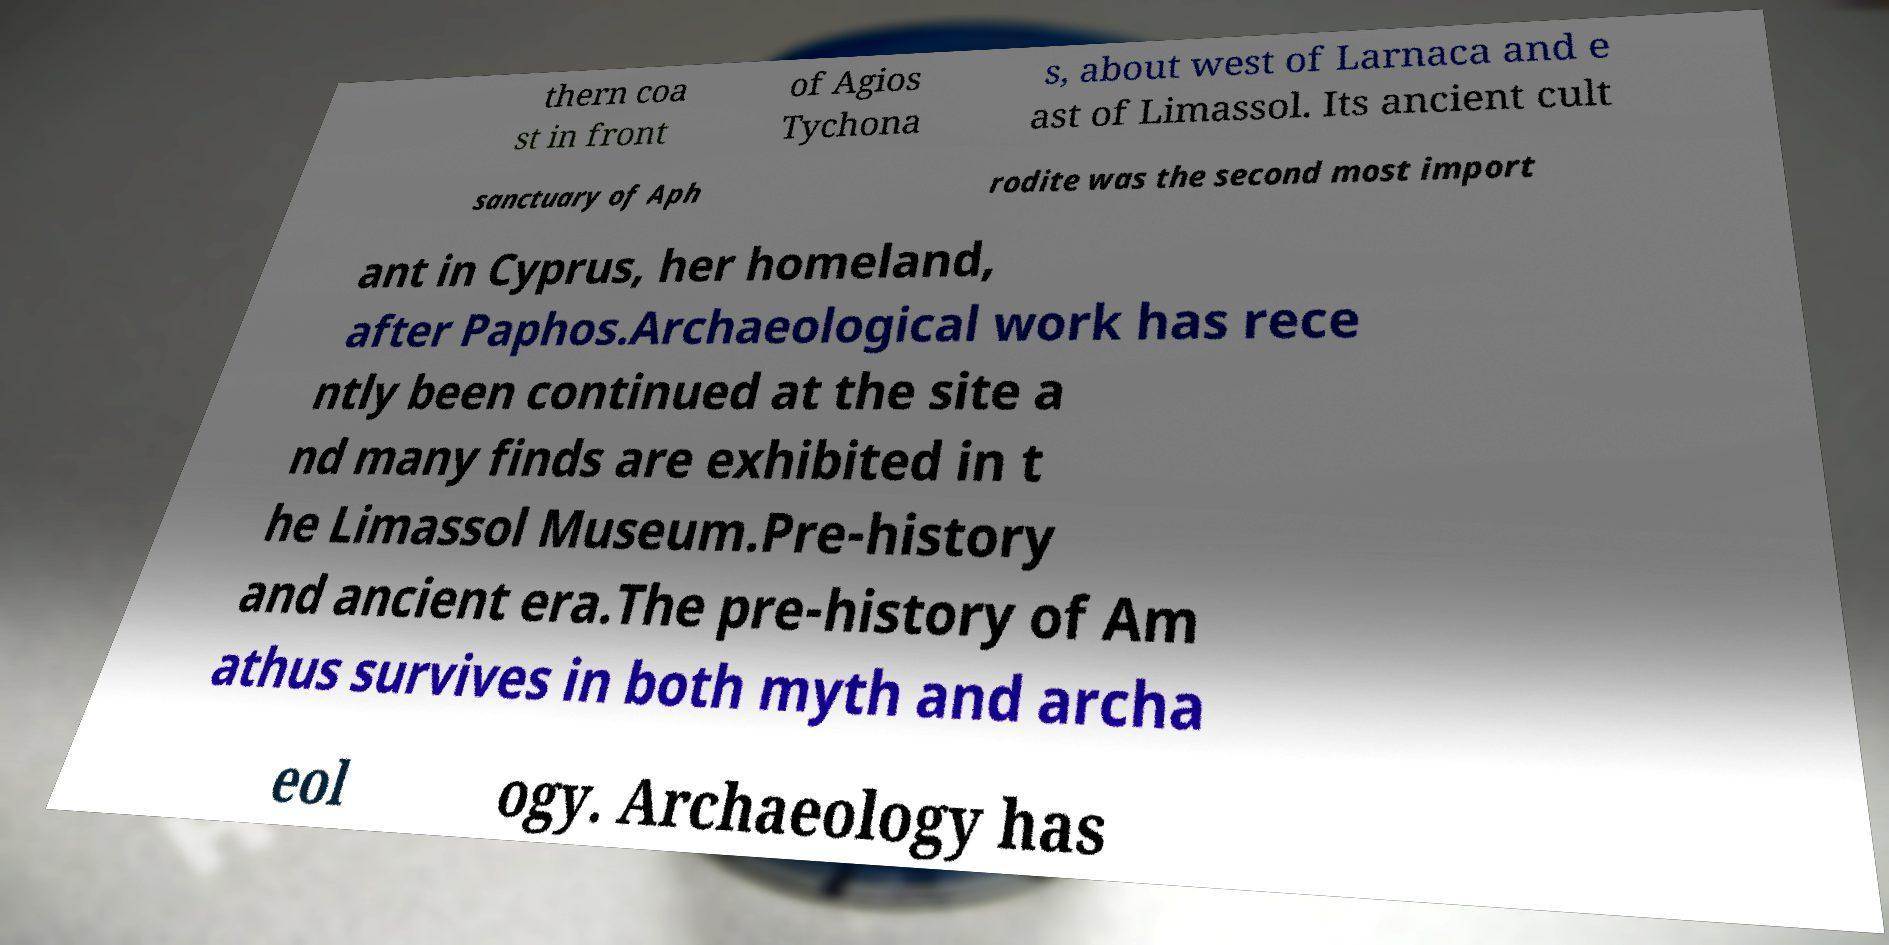There's text embedded in this image that I need extracted. Can you transcribe it verbatim? thern coa st in front of Agios Tychona s, about west of Larnaca and e ast of Limassol. Its ancient cult sanctuary of Aph rodite was the second most import ant in Cyprus, her homeland, after Paphos.Archaeological work has rece ntly been continued at the site a nd many finds are exhibited in t he Limassol Museum.Pre-history and ancient era.The pre-history of Am athus survives in both myth and archa eol ogy. Archaeology has 